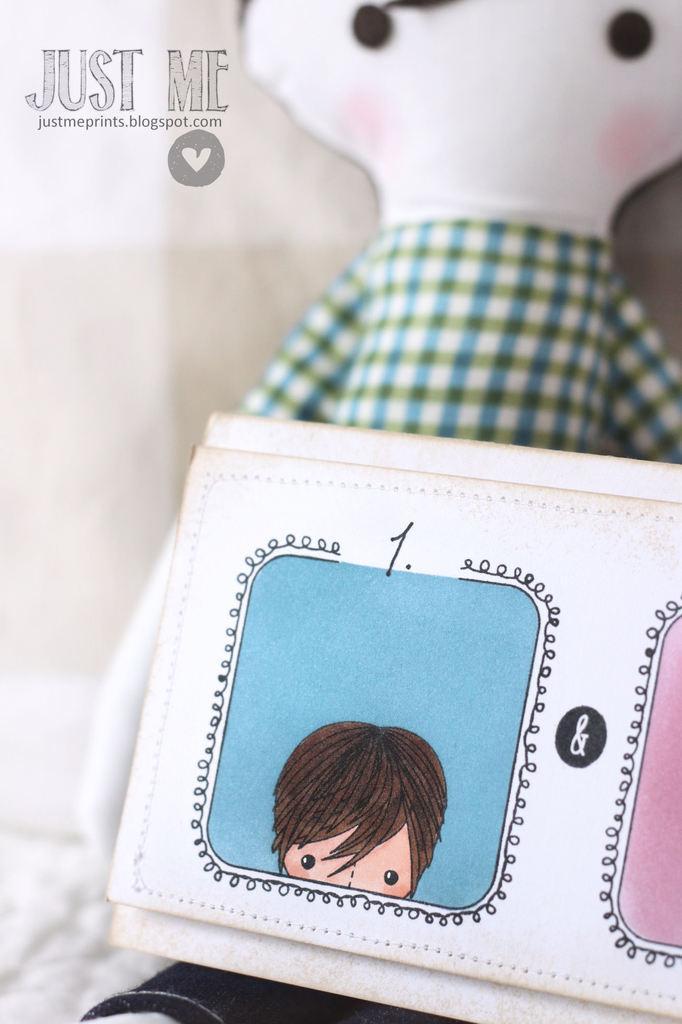Please provide a concise description of this image. In this image we can see white color things with cartoon drawing on it. Behind toy is there. At top left of the image watermark is there. 